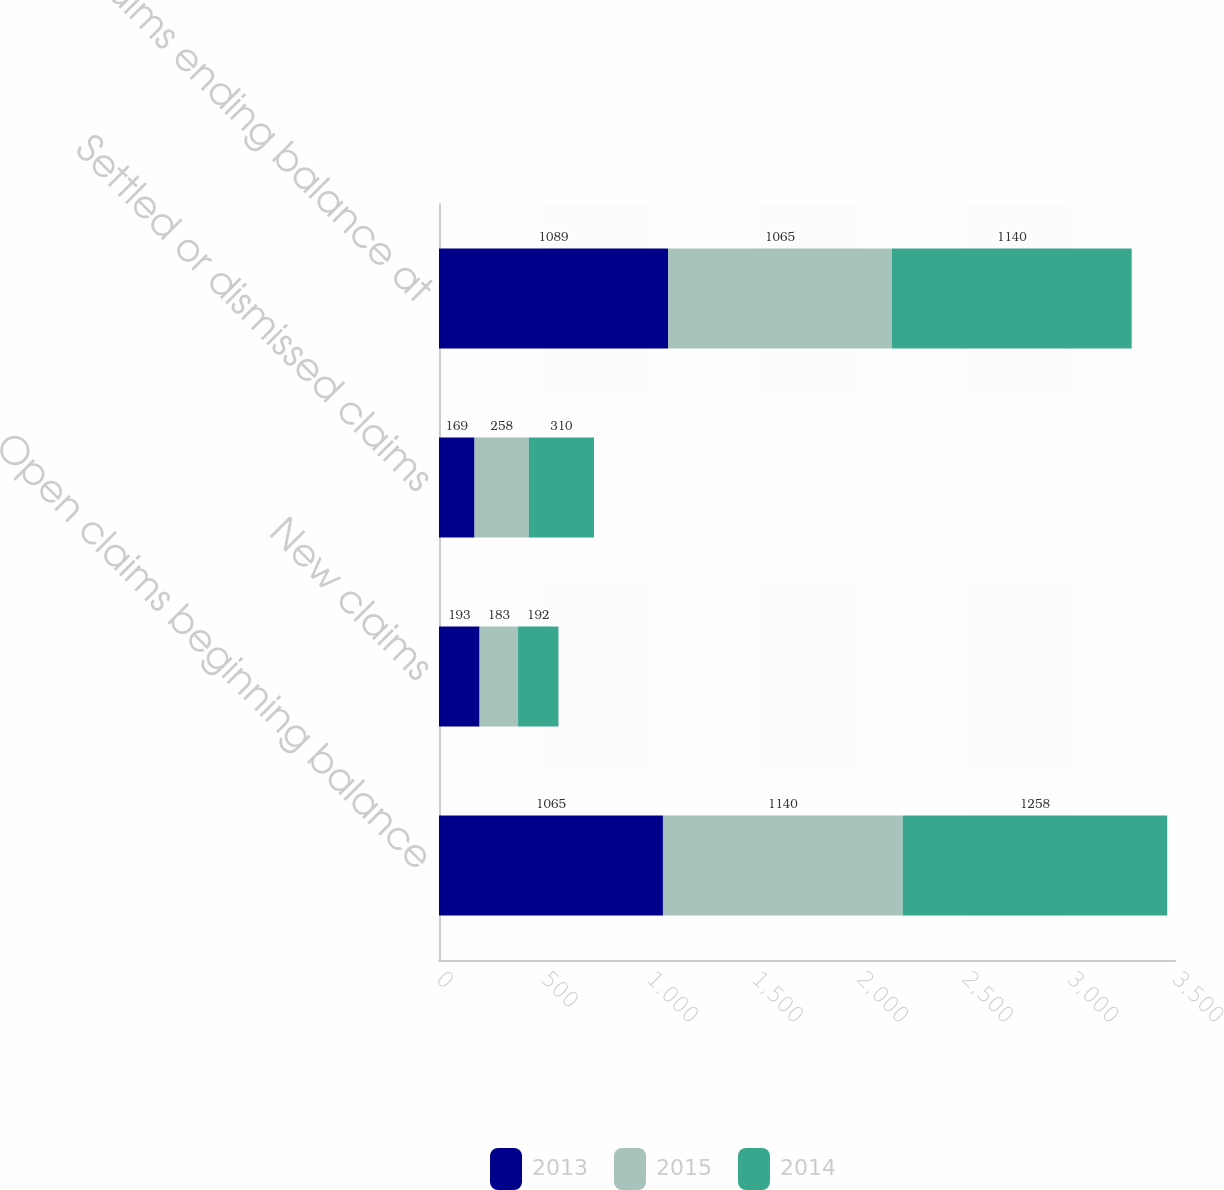Convert chart. <chart><loc_0><loc_0><loc_500><loc_500><stacked_bar_chart><ecel><fcel>Open claims beginning balance<fcel>New claims<fcel>Settled or dismissed claims<fcel>Open claims ending balance at<nl><fcel>2013<fcel>1065<fcel>193<fcel>169<fcel>1089<nl><fcel>2015<fcel>1140<fcel>183<fcel>258<fcel>1065<nl><fcel>2014<fcel>1258<fcel>192<fcel>310<fcel>1140<nl></chart> 